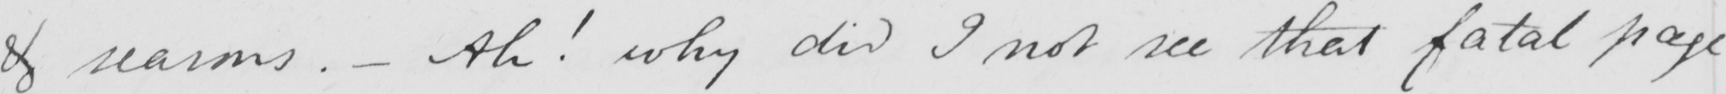What is written in this line of handwriting? & reasons .  _  Ah !  why did I not see that fatal page 